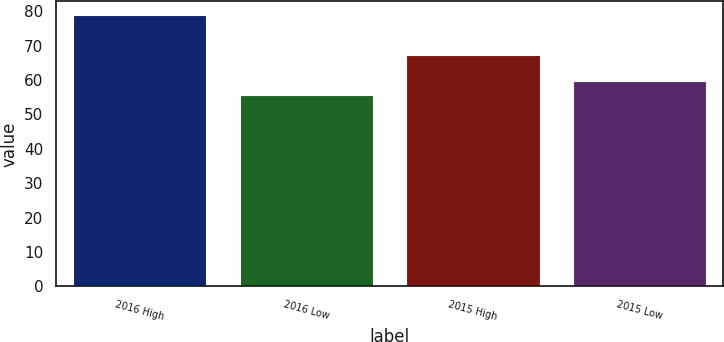Convert chart to OTSL. <chart><loc_0><loc_0><loc_500><loc_500><bar_chart><fcel>2016 High<fcel>2016 Low<fcel>2015 High<fcel>2015 Low<nl><fcel>78.91<fcel>55.54<fcel>67.11<fcel>59.83<nl></chart> 